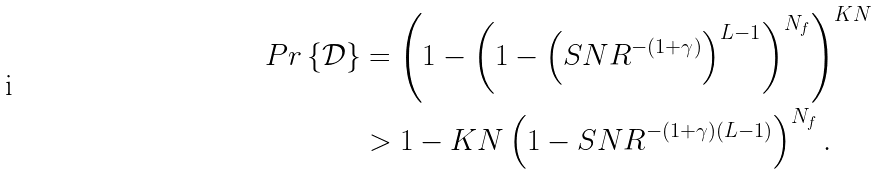<formula> <loc_0><loc_0><loc_500><loc_500>P r \left \{ \mathcal { D } \right \} & = \left ( 1 - \left ( 1 - \left ( S N R ^ { - ( 1 + \gamma ) } \right ) ^ { L - 1 } \right ) ^ { N _ { f } } \right ) ^ { K N } \\ & > 1 - K N \left ( 1 - S N R ^ { - ( 1 + \gamma ) ( L - 1 ) } \right ) ^ { N _ { f } } .</formula> 